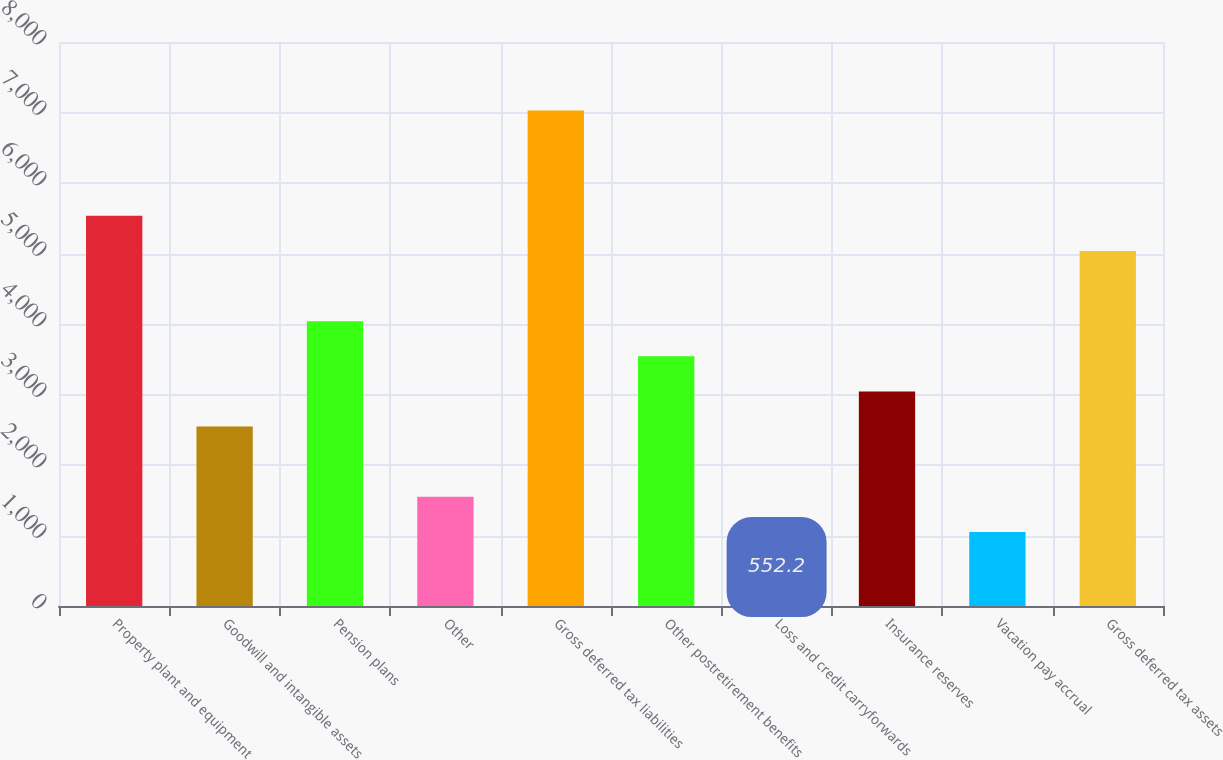Convert chart to OTSL. <chart><loc_0><loc_0><loc_500><loc_500><bar_chart><fcel>Property plant and equipment<fcel>Goodwill and intangible assets<fcel>Pension plans<fcel>Other<fcel>Gross deferred tax liabilities<fcel>Other postretirement benefits<fcel>Loss and credit carryforwards<fcel>Insurance reserves<fcel>Vacation pay accrual<fcel>Gross deferred tax assets<nl><fcel>5534.2<fcel>2545<fcel>4039.6<fcel>1548.6<fcel>7028.8<fcel>3541.4<fcel>552.2<fcel>3043.2<fcel>1050.4<fcel>5036<nl></chart> 